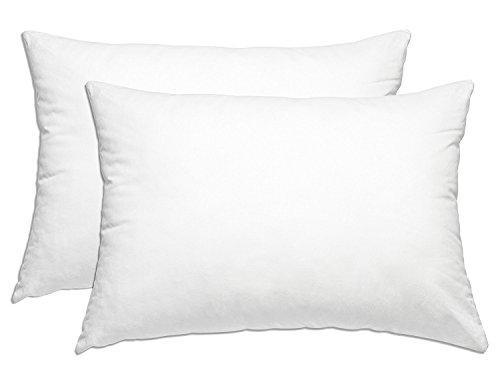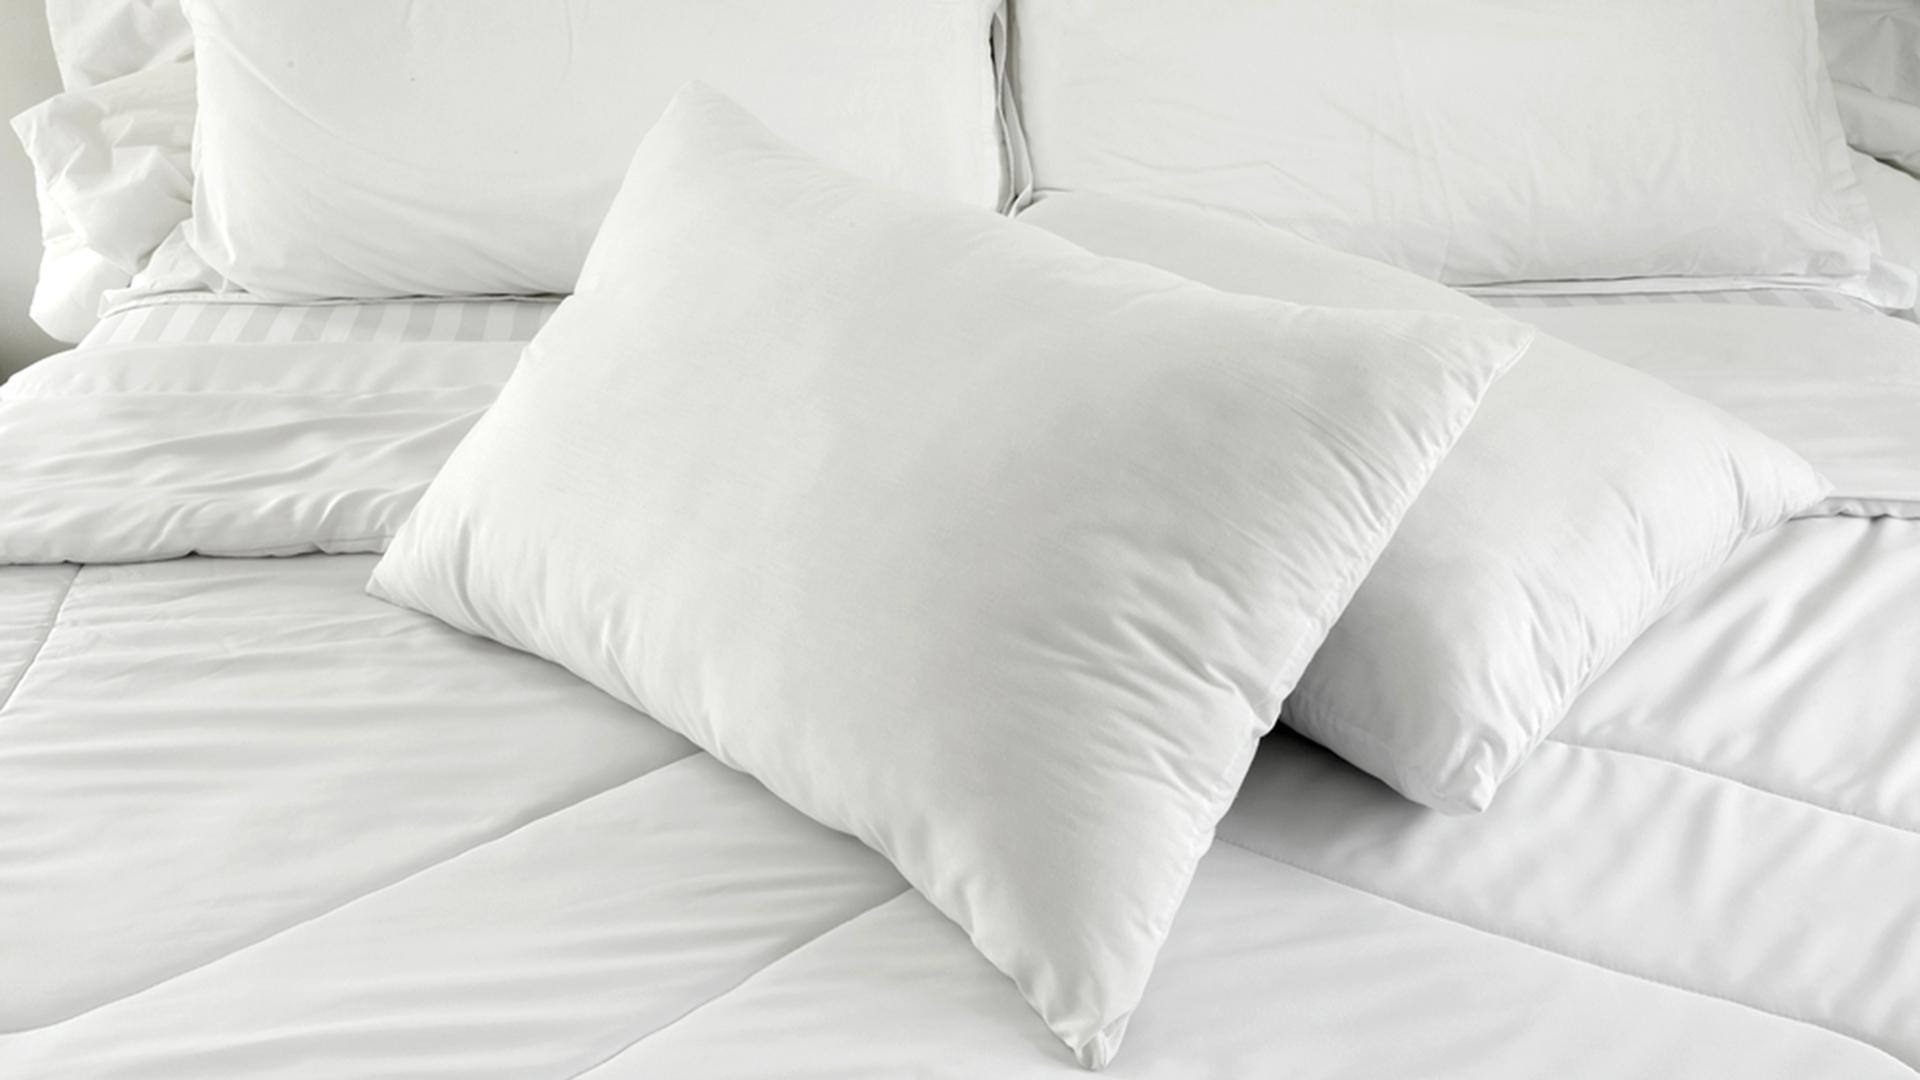The first image is the image on the left, the second image is the image on the right. Given the left and right images, does the statement "Each image shows a bed with white bedding and white pillows, and one image shows a long narrow pillow in front of at least four taller rectangular pillows." hold true? Answer yes or no. No. 